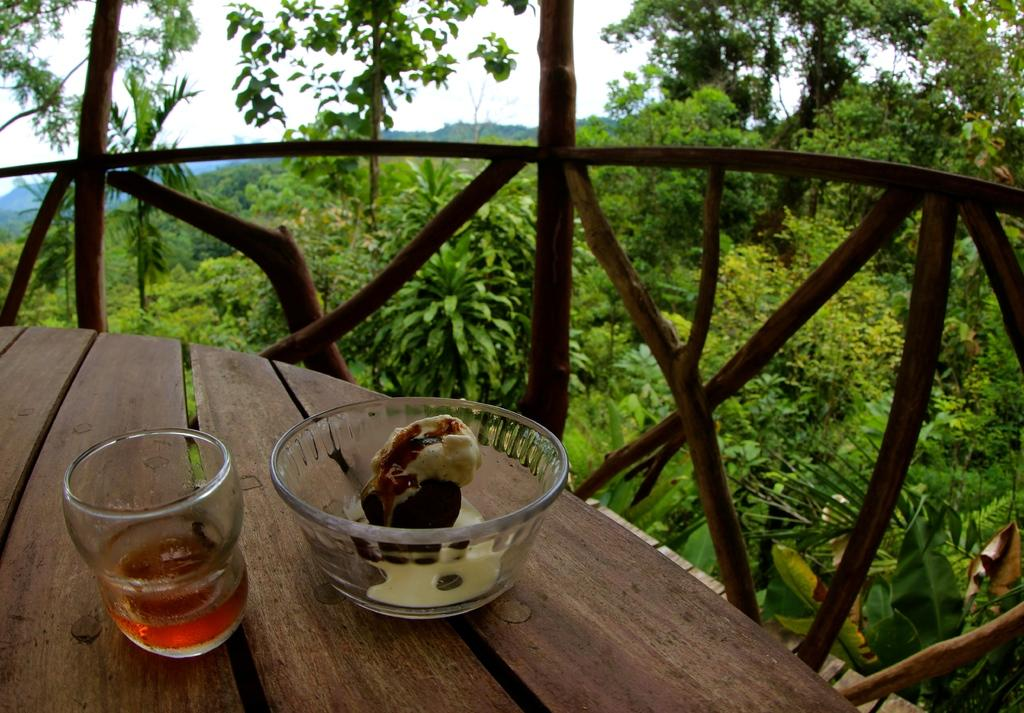What type of dessert is visible in the image? There is an ice cream in the image. What is another item placed on the wooden table top? There is a tea cup in the image. What material is the table top made of? The wooden table top is made of wood. What can be seen in the background of the image? There are trees and plants in the image. What is the wooden railing used for in the image? The wooden railing is likely used for support or as a barrier in the image. What type of silk fabric is draped over the ice cream in the image? There is no silk fabric present in the image; it only features an ice cream and a tea cup on a wooden table top. 